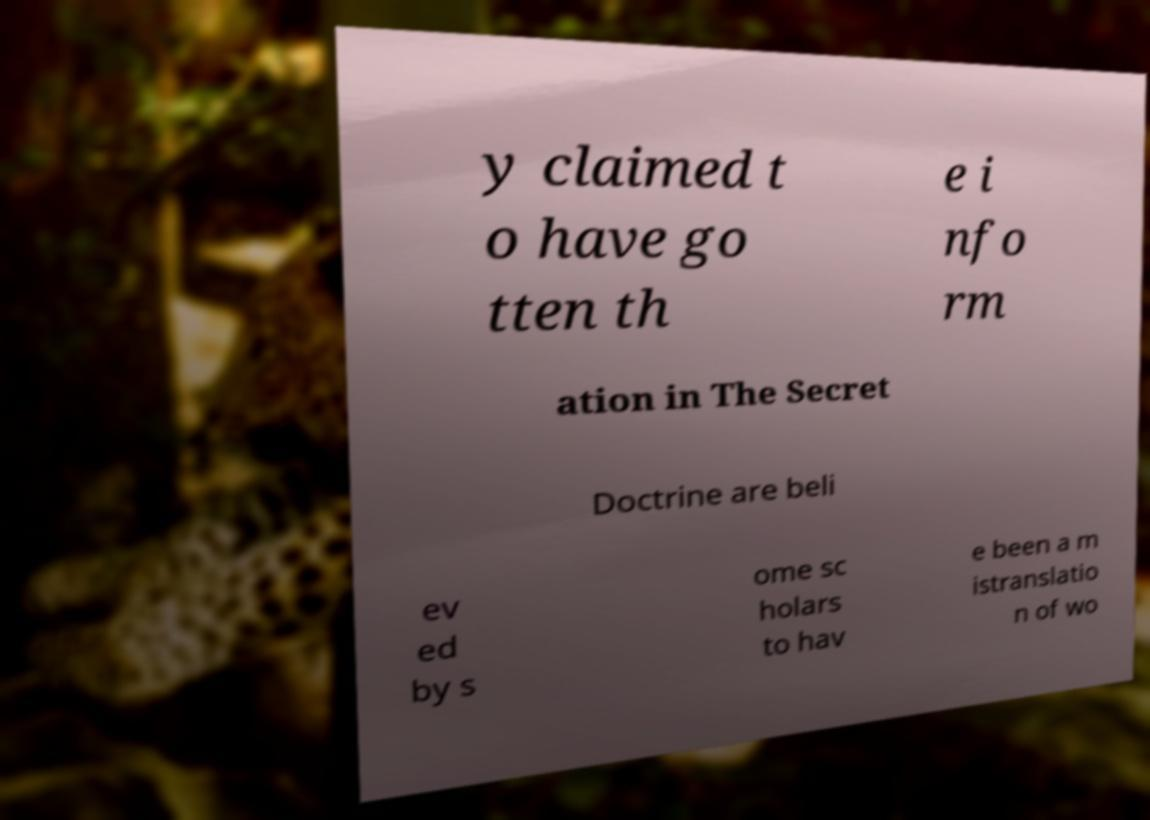There's text embedded in this image that I need extracted. Can you transcribe it verbatim? y claimed t o have go tten th e i nfo rm ation in The Secret Doctrine are beli ev ed by s ome sc holars to hav e been a m istranslatio n of wo 